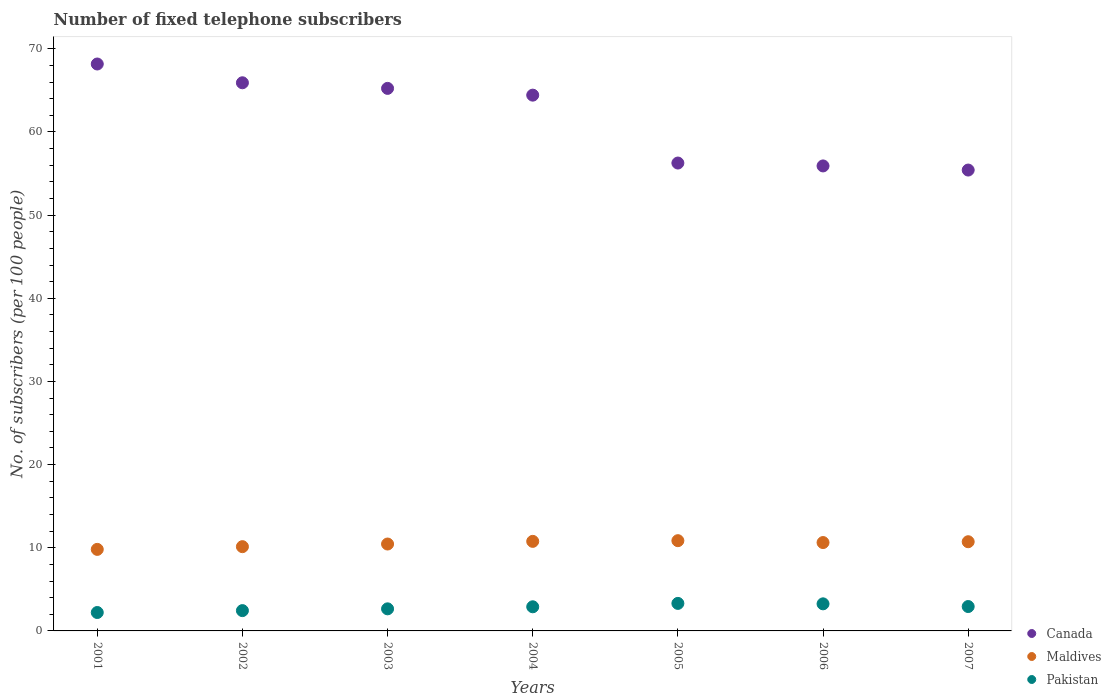How many different coloured dotlines are there?
Provide a succinct answer. 3. What is the number of fixed telephone subscribers in Pakistan in 2004?
Give a very brief answer. 2.9. Across all years, what is the maximum number of fixed telephone subscribers in Canada?
Ensure brevity in your answer.  68.18. Across all years, what is the minimum number of fixed telephone subscribers in Pakistan?
Offer a very short reply. 2.21. In which year was the number of fixed telephone subscribers in Maldives maximum?
Keep it short and to the point. 2005. In which year was the number of fixed telephone subscribers in Canada minimum?
Make the answer very short. 2007. What is the total number of fixed telephone subscribers in Maldives in the graph?
Provide a succinct answer. 73.37. What is the difference between the number of fixed telephone subscribers in Pakistan in 2005 and that in 2007?
Offer a very short reply. 0.38. What is the difference between the number of fixed telephone subscribers in Maldives in 2006 and the number of fixed telephone subscribers in Canada in 2003?
Make the answer very short. -54.62. What is the average number of fixed telephone subscribers in Canada per year?
Ensure brevity in your answer.  61.63. In the year 2003, what is the difference between the number of fixed telephone subscribers in Maldives and number of fixed telephone subscribers in Canada?
Provide a succinct answer. -54.79. In how many years, is the number of fixed telephone subscribers in Canada greater than 38?
Provide a short and direct response. 7. What is the ratio of the number of fixed telephone subscribers in Canada in 2003 to that in 2004?
Ensure brevity in your answer.  1.01. Is the difference between the number of fixed telephone subscribers in Maldives in 2002 and 2005 greater than the difference between the number of fixed telephone subscribers in Canada in 2002 and 2005?
Offer a terse response. No. What is the difference between the highest and the second highest number of fixed telephone subscribers in Canada?
Provide a succinct answer. 2.26. What is the difference between the highest and the lowest number of fixed telephone subscribers in Pakistan?
Give a very brief answer. 1.09. In how many years, is the number of fixed telephone subscribers in Maldives greater than the average number of fixed telephone subscribers in Maldives taken over all years?
Your answer should be very brief. 4. Is it the case that in every year, the sum of the number of fixed telephone subscribers in Pakistan and number of fixed telephone subscribers in Maldives  is greater than the number of fixed telephone subscribers in Canada?
Ensure brevity in your answer.  No. Does the number of fixed telephone subscribers in Canada monotonically increase over the years?
Keep it short and to the point. No. Is the number of fixed telephone subscribers in Pakistan strictly greater than the number of fixed telephone subscribers in Maldives over the years?
Keep it short and to the point. No. Is the number of fixed telephone subscribers in Canada strictly less than the number of fixed telephone subscribers in Pakistan over the years?
Offer a terse response. No. How many dotlines are there?
Your answer should be very brief. 3. How many years are there in the graph?
Provide a short and direct response. 7. Are the values on the major ticks of Y-axis written in scientific E-notation?
Make the answer very short. No. Does the graph contain any zero values?
Your answer should be very brief. No. Does the graph contain grids?
Offer a very short reply. No. How many legend labels are there?
Your response must be concise. 3. How are the legend labels stacked?
Your answer should be very brief. Vertical. What is the title of the graph?
Ensure brevity in your answer.  Number of fixed telephone subscribers. What is the label or title of the X-axis?
Provide a short and direct response. Years. What is the label or title of the Y-axis?
Ensure brevity in your answer.  No. of subscribers (per 100 people). What is the No. of subscribers (per 100 people) in Canada in 2001?
Ensure brevity in your answer.  68.18. What is the No. of subscribers (per 100 people) of Maldives in 2001?
Your response must be concise. 9.81. What is the No. of subscribers (per 100 people) of Pakistan in 2001?
Your response must be concise. 2.21. What is the No. of subscribers (per 100 people) of Canada in 2002?
Ensure brevity in your answer.  65.92. What is the No. of subscribers (per 100 people) in Maldives in 2002?
Make the answer very short. 10.13. What is the No. of subscribers (per 100 people) in Pakistan in 2002?
Provide a short and direct response. 2.44. What is the No. of subscribers (per 100 people) in Canada in 2003?
Give a very brief answer. 65.25. What is the No. of subscribers (per 100 people) in Maldives in 2003?
Provide a succinct answer. 10.45. What is the No. of subscribers (per 100 people) in Pakistan in 2003?
Provide a succinct answer. 2.66. What is the No. of subscribers (per 100 people) of Canada in 2004?
Make the answer very short. 64.43. What is the No. of subscribers (per 100 people) in Maldives in 2004?
Make the answer very short. 10.77. What is the No. of subscribers (per 100 people) in Pakistan in 2004?
Provide a short and direct response. 2.9. What is the No. of subscribers (per 100 people) of Canada in 2005?
Offer a very short reply. 56.27. What is the No. of subscribers (per 100 people) of Maldives in 2005?
Make the answer very short. 10.85. What is the No. of subscribers (per 100 people) of Pakistan in 2005?
Provide a succinct answer. 3.31. What is the No. of subscribers (per 100 people) in Canada in 2006?
Offer a very short reply. 55.92. What is the No. of subscribers (per 100 people) in Maldives in 2006?
Offer a terse response. 10.63. What is the No. of subscribers (per 100 people) in Pakistan in 2006?
Provide a short and direct response. 3.26. What is the No. of subscribers (per 100 people) of Canada in 2007?
Offer a very short reply. 55.42. What is the No. of subscribers (per 100 people) in Maldives in 2007?
Keep it short and to the point. 10.73. What is the No. of subscribers (per 100 people) of Pakistan in 2007?
Provide a succinct answer. 2.93. Across all years, what is the maximum No. of subscribers (per 100 people) of Canada?
Offer a very short reply. 68.18. Across all years, what is the maximum No. of subscribers (per 100 people) in Maldives?
Keep it short and to the point. 10.85. Across all years, what is the maximum No. of subscribers (per 100 people) in Pakistan?
Ensure brevity in your answer.  3.31. Across all years, what is the minimum No. of subscribers (per 100 people) in Canada?
Make the answer very short. 55.42. Across all years, what is the minimum No. of subscribers (per 100 people) of Maldives?
Offer a very short reply. 9.81. Across all years, what is the minimum No. of subscribers (per 100 people) of Pakistan?
Keep it short and to the point. 2.21. What is the total No. of subscribers (per 100 people) of Canada in the graph?
Keep it short and to the point. 431.39. What is the total No. of subscribers (per 100 people) of Maldives in the graph?
Your response must be concise. 73.37. What is the total No. of subscribers (per 100 people) of Pakistan in the graph?
Your response must be concise. 19.71. What is the difference between the No. of subscribers (per 100 people) of Canada in 2001 and that in 2002?
Your response must be concise. 2.26. What is the difference between the No. of subscribers (per 100 people) in Maldives in 2001 and that in 2002?
Ensure brevity in your answer.  -0.33. What is the difference between the No. of subscribers (per 100 people) of Pakistan in 2001 and that in 2002?
Your answer should be very brief. -0.23. What is the difference between the No. of subscribers (per 100 people) of Canada in 2001 and that in 2003?
Your answer should be very brief. 2.93. What is the difference between the No. of subscribers (per 100 people) of Maldives in 2001 and that in 2003?
Offer a very short reply. -0.65. What is the difference between the No. of subscribers (per 100 people) of Pakistan in 2001 and that in 2003?
Provide a succinct answer. -0.44. What is the difference between the No. of subscribers (per 100 people) of Canada in 2001 and that in 2004?
Ensure brevity in your answer.  3.75. What is the difference between the No. of subscribers (per 100 people) of Maldives in 2001 and that in 2004?
Your answer should be very brief. -0.96. What is the difference between the No. of subscribers (per 100 people) in Pakistan in 2001 and that in 2004?
Provide a succinct answer. -0.69. What is the difference between the No. of subscribers (per 100 people) in Canada in 2001 and that in 2005?
Offer a very short reply. 11.91. What is the difference between the No. of subscribers (per 100 people) of Maldives in 2001 and that in 2005?
Your answer should be very brief. -1.05. What is the difference between the No. of subscribers (per 100 people) in Pakistan in 2001 and that in 2005?
Offer a very short reply. -1.09. What is the difference between the No. of subscribers (per 100 people) in Canada in 2001 and that in 2006?
Make the answer very short. 12.26. What is the difference between the No. of subscribers (per 100 people) of Maldives in 2001 and that in 2006?
Give a very brief answer. -0.82. What is the difference between the No. of subscribers (per 100 people) of Pakistan in 2001 and that in 2006?
Provide a short and direct response. -1.04. What is the difference between the No. of subscribers (per 100 people) in Canada in 2001 and that in 2007?
Make the answer very short. 12.75. What is the difference between the No. of subscribers (per 100 people) in Maldives in 2001 and that in 2007?
Provide a succinct answer. -0.92. What is the difference between the No. of subscribers (per 100 people) in Pakistan in 2001 and that in 2007?
Your answer should be compact. -0.72. What is the difference between the No. of subscribers (per 100 people) of Canada in 2002 and that in 2003?
Offer a terse response. 0.67. What is the difference between the No. of subscribers (per 100 people) in Maldives in 2002 and that in 2003?
Your response must be concise. -0.32. What is the difference between the No. of subscribers (per 100 people) of Pakistan in 2002 and that in 2003?
Provide a short and direct response. -0.21. What is the difference between the No. of subscribers (per 100 people) in Canada in 2002 and that in 2004?
Make the answer very short. 1.49. What is the difference between the No. of subscribers (per 100 people) of Maldives in 2002 and that in 2004?
Make the answer very short. -0.64. What is the difference between the No. of subscribers (per 100 people) of Pakistan in 2002 and that in 2004?
Give a very brief answer. -0.46. What is the difference between the No. of subscribers (per 100 people) in Canada in 2002 and that in 2005?
Give a very brief answer. 9.65. What is the difference between the No. of subscribers (per 100 people) in Maldives in 2002 and that in 2005?
Provide a short and direct response. -0.72. What is the difference between the No. of subscribers (per 100 people) of Pakistan in 2002 and that in 2005?
Keep it short and to the point. -0.87. What is the difference between the No. of subscribers (per 100 people) of Canada in 2002 and that in 2006?
Ensure brevity in your answer.  10. What is the difference between the No. of subscribers (per 100 people) in Maldives in 2002 and that in 2006?
Your response must be concise. -0.49. What is the difference between the No. of subscribers (per 100 people) in Pakistan in 2002 and that in 2006?
Keep it short and to the point. -0.81. What is the difference between the No. of subscribers (per 100 people) in Canada in 2002 and that in 2007?
Provide a short and direct response. 10.5. What is the difference between the No. of subscribers (per 100 people) in Maldives in 2002 and that in 2007?
Ensure brevity in your answer.  -0.59. What is the difference between the No. of subscribers (per 100 people) in Pakistan in 2002 and that in 2007?
Provide a succinct answer. -0.49. What is the difference between the No. of subscribers (per 100 people) in Canada in 2003 and that in 2004?
Offer a terse response. 0.81. What is the difference between the No. of subscribers (per 100 people) in Maldives in 2003 and that in 2004?
Keep it short and to the point. -0.32. What is the difference between the No. of subscribers (per 100 people) of Pakistan in 2003 and that in 2004?
Provide a succinct answer. -0.25. What is the difference between the No. of subscribers (per 100 people) in Canada in 2003 and that in 2005?
Offer a terse response. 8.98. What is the difference between the No. of subscribers (per 100 people) of Maldives in 2003 and that in 2005?
Make the answer very short. -0.4. What is the difference between the No. of subscribers (per 100 people) of Pakistan in 2003 and that in 2005?
Keep it short and to the point. -0.65. What is the difference between the No. of subscribers (per 100 people) in Canada in 2003 and that in 2006?
Provide a short and direct response. 9.33. What is the difference between the No. of subscribers (per 100 people) in Maldives in 2003 and that in 2006?
Make the answer very short. -0.18. What is the difference between the No. of subscribers (per 100 people) of Pakistan in 2003 and that in 2006?
Provide a short and direct response. -0.6. What is the difference between the No. of subscribers (per 100 people) in Canada in 2003 and that in 2007?
Give a very brief answer. 9.82. What is the difference between the No. of subscribers (per 100 people) of Maldives in 2003 and that in 2007?
Your response must be concise. -0.28. What is the difference between the No. of subscribers (per 100 people) in Pakistan in 2003 and that in 2007?
Your response must be concise. -0.28. What is the difference between the No. of subscribers (per 100 people) in Canada in 2004 and that in 2005?
Give a very brief answer. 8.16. What is the difference between the No. of subscribers (per 100 people) of Maldives in 2004 and that in 2005?
Offer a terse response. -0.08. What is the difference between the No. of subscribers (per 100 people) of Pakistan in 2004 and that in 2005?
Provide a short and direct response. -0.41. What is the difference between the No. of subscribers (per 100 people) in Canada in 2004 and that in 2006?
Make the answer very short. 8.51. What is the difference between the No. of subscribers (per 100 people) of Maldives in 2004 and that in 2006?
Give a very brief answer. 0.14. What is the difference between the No. of subscribers (per 100 people) in Pakistan in 2004 and that in 2006?
Keep it short and to the point. -0.35. What is the difference between the No. of subscribers (per 100 people) in Canada in 2004 and that in 2007?
Offer a very short reply. 9.01. What is the difference between the No. of subscribers (per 100 people) in Maldives in 2004 and that in 2007?
Offer a very short reply. 0.04. What is the difference between the No. of subscribers (per 100 people) in Pakistan in 2004 and that in 2007?
Your answer should be very brief. -0.03. What is the difference between the No. of subscribers (per 100 people) of Canada in 2005 and that in 2006?
Provide a short and direct response. 0.35. What is the difference between the No. of subscribers (per 100 people) in Maldives in 2005 and that in 2006?
Your answer should be very brief. 0.23. What is the difference between the No. of subscribers (per 100 people) of Pakistan in 2005 and that in 2006?
Keep it short and to the point. 0.05. What is the difference between the No. of subscribers (per 100 people) in Canada in 2005 and that in 2007?
Keep it short and to the point. 0.84. What is the difference between the No. of subscribers (per 100 people) of Maldives in 2005 and that in 2007?
Give a very brief answer. 0.13. What is the difference between the No. of subscribers (per 100 people) of Pakistan in 2005 and that in 2007?
Provide a short and direct response. 0.38. What is the difference between the No. of subscribers (per 100 people) of Canada in 2006 and that in 2007?
Keep it short and to the point. 0.5. What is the difference between the No. of subscribers (per 100 people) of Maldives in 2006 and that in 2007?
Give a very brief answer. -0.1. What is the difference between the No. of subscribers (per 100 people) in Pakistan in 2006 and that in 2007?
Your response must be concise. 0.32. What is the difference between the No. of subscribers (per 100 people) in Canada in 2001 and the No. of subscribers (per 100 people) in Maldives in 2002?
Keep it short and to the point. 58.04. What is the difference between the No. of subscribers (per 100 people) in Canada in 2001 and the No. of subscribers (per 100 people) in Pakistan in 2002?
Give a very brief answer. 65.74. What is the difference between the No. of subscribers (per 100 people) in Maldives in 2001 and the No. of subscribers (per 100 people) in Pakistan in 2002?
Provide a succinct answer. 7.36. What is the difference between the No. of subscribers (per 100 people) of Canada in 2001 and the No. of subscribers (per 100 people) of Maldives in 2003?
Ensure brevity in your answer.  57.73. What is the difference between the No. of subscribers (per 100 people) in Canada in 2001 and the No. of subscribers (per 100 people) in Pakistan in 2003?
Your response must be concise. 65.52. What is the difference between the No. of subscribers (per 100 people) of Maldives in 2001 and the No. of subscribers (per 100 people) of Pakistan in 2003?
Ensure brevity in your answer.  7.15. What is the difference between the No. of subscribers (per 100 people) of Canada in 2001 and the No. of subscribers (per 100 people) of Maldives in 2004?
Give a very brief answer. 57.41. What is the difference between the No. of subscribers (per 100 people) of Canada in 2001 and the No. of subscribers (per 100 people) of Pakistan in 2004?
Your answer should be very brief. 65.28. What is the difference between the No. of subscribers (per 100 people) in Maldives in 2001 and the No. of subscribers (per 100 people) in Pakistan in 2004?
Make the answer very short. 6.9. What is the difference between the No. of subscribers (per 100 people) in Canada in 2001 and the No. of subscribers (per 100 people) in Maldives in 2005?
Offer a very short reply. 57.32. What is the difference between the No. of subscribers (per 100 people) of Canada in 2001 and the No. of subscribers (per 100 people) of Pakistan in 2005?
Keep it short and to the point. 64.87. What is the difference between the No. of subscribers (per 100 people) of Maldives in 2001 and the No. of subscribers (per 100 people) of Pakistan in 2005?
Make the answer very short. 6.5. What is the difference between the No. of subscribers (per 100 people) in Canada in 2001 and the No. of subscribers (per 100 people) in Maldives in 2006?
Offer a terse response. 57.55. What is the difference between the No. of subscribers (per 100 people) of Canada in 2001 and the No. of subscribers (per 100 people) of Pakistan in 2006?
Offer a terse response. 64.92. What is the difference between the No. of subscribers (per 100 people) in Maldives in 2001 and the No. of subscribers (per 100 people) in Pakistan in 2006?
Make the answer very short. 6.55. What is the difference between the No. of subscribers (per 100 people) in Canada in 2001 and the No. of subscribers (per 100 people) in Maldives in 2007?
Make the answer very short. 57.45. What is the difference between the No. of subscribers (per 100 people) in Canada in 2001 and the No. of subscribers (per 100 people) in Pakistan in 2007?
Keep it short and to the point. 65.25. What is the difference between the No. of subscribers (per 100 people) in Maldives in 2001 and the No. of subscribers (per 100 people) in Pakistan in 2007?
Your answer should be very brief. 6.87. What is the difference between the No. of subscribers (per 100 people) in Canada in 2002 and the No. of subscribers (per 100 people) in Maldives in 2003?
Give a very brief answer. 55.47. What is the difference between the No. of subscribers (per 100 people) of Canada in 2002 and the No. of subscribers (per 100 people) of Pakistan in 2003?
Offer a terse response. 63.26. What is the difference between the No. of subscribers (per 100 people) in Maldives in 2002 and the No. of subscribers (per 100 people) in Pakistan in 2003?
Provide a short and direct response. 7.48. What is the difference between the No. of subscribers (per 100 people) in Canada in 2002 and the No. of subscribers (per 100 people) in Maldives in 2004?
Provide a succinct answer. 55.15. What is the difference between the No. of subscribers (per 100 people) in Canada in 2002 and the No. of subscribers (per 100 people) in Pakistan in 2004?
Offer a very short reply. 63.02. What is the difference between the No. of subscribers (per 100 people) in Maldives in 2002 and the No. of subscribers (per 100 people) in Pakistan in 2004?
Make the answer very short. 7.23. What is the difference between the No. of subscribers (per 100 people) of Canada in 2002 and the No. of subscribers (per 100 people) of Maldives in 2005?
Give a very brief answer. 55.07. What is the difference between the No. of subscribers (per 100 people) in Canada in 2002 and the No. of subscribers (per 100 people) in Pakistan in 2005?
Your answer should be very brief. 62.61. What is the difference between the No. of subscribers (per 100 people) of Maldives in 2002 and the No. of subscribers (per 100 people) of Pakistan in 2005?
Offer a very short reply. 6.82. What is the difference between the No. of subscribers (per 100 people) of Canada in 2002 and the No. of subscribers (per 100 people) of Maldives in 2006?
Give a very brief answer. 55.29. What is the difference between the No. of subscribers (per 100 people) of Canada in 2002 and the No. of subscribers (per 100 people) of Pakistan in 2006?
Your response must be concise. 62.66. What is the difference between the No. of subscribers (per 100 people) of Maldives in 2002 and the No. of subscribers (per 100 people) of Pakistan in 2006?
Offer a very short reply. 6.88. What is the difference between the No. of subscribers (per 100 people) of Canada in 2002 and the No. of subscribers (per 100 people) of Maldives in 2007?
Provide a succinct answer. 55.19. What is the difference between the No. of subscribers (per 100 people) of Canada in 2002 and the No. of subscribers (per 100 people) of Pakistan in 2007?
Your response must be concise. 62.99. What is the difference between the No. of subscribers (per 100 people) of Maldives in 2002 and the No. of subscribers (per 100 people) of Pakistan in 2007?
Provide a short and direct response. 7.2. What is the difference between the No. of subscribers (per 100 people) of Canada in 2003 and the No. of subscribers (per 100 people) of Maldives in 2004?
Give a very brief answer. 54.48. What is the difference between the No. of subscribers (per 100 people) in Canada in 2003 and the No. of subscribers (per 100 people) in Pakistan in 2004?
Your answer should be very brief. 62.34. What is the difference between the No. of subscribers (per 100 people) in Maldives in 2003 and the No. of subscribers (per 100 people) in Pakistan in 2004?
Keep it short and to the point. 7.55. What is the difference between the No. of subscribers (per 100 people) in Canada in 2003 and the No. of subscribers (per 100 people) in Maldives in 2005?
Ensure brevity in your answer.  54.39. What is the difference between the No. of subscribers (per 100 people) in Canada in 2003 and the No. of subscribers (per 100 people) in Pakistan in 2005?
Provide a succinct answer. 61.94. What is the difference between the No. of subscribers (per 100 people) of Maldives in 2003 and the No. of subscribers (per 100 people) of Pakistan in 2005?
Give a very brief answer. 7.14. What is the difference between the No. of subscribers (per 100 people) of Canada in 2003 and the No. of subscribers (per 100 people) of Maldives in 2006?
Your answer should be very brief. 54.62. What is the difference between the No. of subscribers (per 100 people) in Canada in 2003 and the No. of subscribers (per 100 people) in Pakistan in 2006?
Offer a very short reply. 61.99. What is the difference between the No. of subscribers (per 100 people) in Maldives in 2003 and the No. of subscribers (per 100 people) in Pakistan in 2006?
Your answer should be compact. 7.19. What is the difference between the No. of subscribers (per 100 people) in Canada in 2003 and the No. of subscribers (per 100 people) in Maldives in 2007?
Give a very brief answer. 54.52. What is the difference between the No. of subscribers (per 100 people) of Canada in 2003 and the No. of subscribers (per 100 people) of Pakistan in 2007?
Provide a succinct answer. 62.31. What is the difference between the No. of subscribers (per 100 people) of Maldives in 2003 and the No. of subscribers (per 100 people) of Pakistan in 2007?
Provide a succinct answer. 7.52. What is the difference between the No. of subscribers (per 100 people) in Canada in 2004 and the No. of subscribers (per 100 people) in Maldives in 2005?
Offer a terse response. 53.58. What is the difference between the No. of subscribers (per 100 people) in Canada in 2004 and the No. of subscribers (per 100 people) in Pakistan in 2005?
Provide a short and direct response. 61.12. What is the difference between the No. of subscribers (per 100 people) of Maldives in 2004 and the No. of subscribers (per 100 people) of Pakistan in 2005?
Your answer should be very brief. 7.46. What is the difference between the No. of subscribers (per 100 people) in Canada in 2004 and the No. of subscribers (per 100 people) in Maldives in 2006?
Your response must be concise. 53.81. What is the difference between the No. of subscribers (per 100 people) in Canada in 2004 and the No. of subscribers (per 100 people) in Pakistan in 2006?
Offer a very short reply. 61.18. What is the difference between the No. of subscribers (per 100 people) in Maldives in 2004 and the No. of subscribers (per 100 people) in Pakistan in 2006?
Your response must be concise. 7.51. What is the difference between the No. of subscribers (per 100 people) of Canada in 2004 and the No. of subscribers (per 100 people) of Maldives in 2007?
Provide a short and direct response. 53.71. What is the difference between the No. of subscribers (per 100 people) in Canada in 2004 and the No. of subscribers (per 100 people) in Pakistan in 2007?
Offer a terse response. 61.5. What is the difference between the No. of subscribers (per 100 people) of Maldives in 2004 and the No. of subscribers (per 100 people) of Pakistan in 2007?
Make the answer very short. 7.84. What is the difference between the No. of subscribers (per 100 people) in Canada in 2005 and the No. of subscribers (per 100 people) in Maldives in 2006?
Offer a terse response. 45.64. What is the difference between the No. of subscribers (per 100 people) of Canada in 2005 and the No. of subscribers (per 100 people) of Pakistan in 2006?
Your answer should be compact. 53.01. What is the difference between the No. of subscribers (per 100 people) of Maldives in 2005 and the No. of subscribers (per 100 people) of Pakistan in 2006?
Provide a short and direct response. 7.6. What is the difference between the No. of subscribers (per 100 people) of Canada in 2005 and the No. of subscribers (per 100 people) of Maldives in 2007?
Your response must be concise. 45.54. What is the difference between the No. of subscribers (per 100 people) in Canada in 2005 and the No. of subscribers (per 100 people) in Pakistan in 2007?
Keep it short and to the point. 53.34. What is the difference between the No. of subscribers (per 100 people) in Maldives in 2005 and the No. of subscribers (per 100 people) in Pakistan in 2007?
Offer a terse response. 7.92. What is the difference between the No. of subscribers (per 100 people) of Canada in 2006 and the No. of subscribers (per 100 people) of Maldives in 2007?
Offer a terse response. 45.19. What is the difference between the No. of subscribers (per 100 people) of Canada in 2006 and the No. of subscribers (per 100 people) of Pakistan in 2007?
Provide a succinct answer. 52.99. What is the difference between the No. of subscribers (per 100 people) in Maldives in 2006 and the No. of subscribers (per 100 people) in Pakistan in 2007?
Offer a very short reply. 7.7. What is the average No. of subscribers (per 100 people) in Canada per year?
Provide a short and direct response. 61.63. What is the average No. of subscribers (per 100 people) of Maldives per year?
Offer a very short reply. 10.48. What is the average No. of subscribers (per 100 people) in Pakistan per year?
Make the answer very short. 2.82. In the year 2001, what is the difference between the No. of subscribers (per 100 people) of Canada and No. of subscribers (per 100 people) of Maldives?
Offer a very short reply. 58.37. In the year 2001, what is the difference between the No. of subscribers (per 100 people) in Canada and No. of subscribers (per 100 people) in Pakistan?
Offer a terse response. 65.96. In the year 2001, what is the difference between the No. of subscribers (per 100 people) in Maldives and No. of subscribers (per 100 people) in Pakistan?
Your answer should be very brief. 7.59. In the year 2002, what is the difference between the No. of subscribers (per 100 people) in Canada and No. of subscribers (per 100 people) in Maldives?
Provide a short and direct response. 55.79. In the year 2002, what is the difference between the No. of subscribers (per 100 people) in Canada and No. of subscribers (per 100 people) in Pakistan?
Your response must be concise. 63.48. In the year 2002, what is the difference between the No. of subscribers (per 100 people) in Maldives and No. of subscribers (per 100 people) in Pakistan?
Your answer should be very brief. 7.69. In the year 2003, what is the difference between the No. of subscribers (per 100 people) of Canada and No. of subscribers (per 100 people) of Maldives?
Your answer should be very brief. 54.79. In the year 2003, what is the difference between the No. of subscribers (per 100 people) in Canada and No. of subscribers (per 100 people) in Pakistan?
Make the answer very short. 62.59. In the year 2003, what is the difference between the No. of subscribers (per 100 people) of Maldives and No. of subscribers (per 100 people) of Pakistan?
Offer a very short reply. 7.8. In the year 2004, what is the difference between the No. of subscribers (per 100 people) in Canada and No. of subscribers (per 100 people) in Maldives?
Offer a terse response. 53.66. In the year 2004, what is the difference between the No. of subscribers (per 100 people) of Canada and No. of subscribers (per 100 people) of Pakistan?
Your response must be concise. 61.53. In the year 2004, what is the difference between the No. of subscribers (per 100 people) in Maldives and No. of subscribers (per 100 people) in Pakistan?
Provide a short and direct response. 7.87. In the year 2005, what is the difference between the No. of subscribers (per 100 people) in Canada and No. of subscribers (per 100 people) in Maldives?
Keep it short and to the point. 45.41. In the year 2005, what is the difference between the No. of subscribers (per 100 people) of Canada and No. of subscribers (per 100 people) of Pakistan?
Your answer should be compact. 52.96. In the year 2005, what is the difference between the No. of subscribers (per 100 people) in Maldives and No. of subscribers (per 100 people) in Pakistan?
Make the answer very short. 7.54. In the year 2006, what is the difference between the No. of subscribers (per 100 people) of Canada and No. of subscribers (per 100 people) of Maldives?
Keep it short and to the point. 45.29. In the year 2006, what is the difference between the No. of subscribers (per 100 people) of Canada and No. of subscribers (per 100 people) of Pakistan?
Give a very brief answer. 52.66. In the year 2006, what is the difference between the No. of subscribers (per 100 people) in Maldives and No. of subscribers (per 100 people) in Pakistan?
Give a very brief answer. 7.37. In the year 2007, what is the difference between the No. of subscribers (per 100 people) of Canada and No. of subscribers (per 100 people) of Maldives?
Give a very brief answer. 44.7. In the year 2007, what is the difference between the No. of subscribers (per 100 people) in Canada and No. of subscribers (per 100 people) in Pakistan?
Your answer should be compact. 52.49. In the year 2007, what is the difference between the No. of subscribers (per 100 people) in Maldives and No. of subscribers (per 100 people) in Pakistan?
Offer a terse response. 7.79. What is the ratio of the No. of subscribers (per 100 people) in Canada in 2001 to that in 2002?
Provide a succinct answer. 1.03. What is the ratio of the No. of subscribers (per 100 people) in Pakistan in 2001 to that in 2002?
Your response must be concise. 0.91. What is the ratio of the No. of subscribers (per 100 people) in Canada in 2001 to that in 2003?
Offer a very short reply. 1.04. What is the ratio of the No. of subscribers (per 100 people) in Maldives in 2001 to that in 2003?
Give a very brief answer. 0.94. What is the ratio of the No. of subscribers (per 100 people) in Pakistan in 2001 to that in 2003?
Give a very brief answer. 0.83. What is the ratio of the No. of subscribers (per 100 people) of Canada in 2001 to that in 2004?
Ensure brevity in your answer.  1.06. What is the ratio of the No. of subscribers (per 100 people) in Maldives in 2001 to that in 2004?
Offer a terse response. 0.91. What is the ratio of the No. of subscribers (per 100 people) in Pakistan in 2001 to that in 2004?
Make the answer very short. 0.76. What is the ratio of the No. of subscribers (per 100 people) of Canada in 2001 to that in 2005?
Your answer should be compact. 1.21. What is the ratio of the No. of subscribers (per 100 people) in Maldives in 2001 to that in 2005?
Provide a short and direct response. 0.9. What is the ratio of the No. of subscribers (per 100 people) of Pakistan in 2001 to that in 2005?
Offer a very short reply. 0.67. What is the ratio of the No. of subscribers (per 100 people) of Canada in 2001 to that in 2006?
Offer a very short reply. 1.22. What is the ratio of the No. of subscribers (per 100 people) in Maldives in 2001 to that in 2006?
Offer a very short reply. 0.92. What is the ratio of the No. of subscribers (per 100 people) of Pakistan in 2001 to that in 2006?
Offer a terse response. 0.68. What is the ratio of the No. of subscribers (per 100 people) in Canada in 2001 to that in 2007?
Provide a short and direct response. 1.23. What is the ratio of the No. of subscribers (per 100 people) of Maldives in 2001 to that in 2007?
Give a very brief answer. 0.91. What is the ratio of the No. of subscribers (per 100 people) of Pakistan in 2001 to that in 2007?
Provide a succinct answer. 0.76. What is the ratio of the No. of subscribers (per 100 people) in Canada in 2002 to that in 2003?
Make the answer very short. 1.01. What is the ratio of the No. of subscribers (per 100 people) in Maldives in 2002 to that in 2003?
Your answer should be very brief. 0.97. What is the ratio of the No. of subscribers (per 100 people) of Pakistan in 2002 to that in 2003?
Offer a terse response. 0.92. What is the ratio of the No. of subscribers (per 100 people) of Canada in 2002 to that in 2004?
Offer a terse response. 1.02. What is the ratio of the No. of subscribers (per 100 people) in Maldives in 2002 to that in 2004?
Provide a short and direct response. 0.94. What is the ratio of the No. of subscribers (per 100 people) in Pakistan in 2002 to that in 2004?
Your answer should be very brief. 0.84. What is the ratio of the No. of subscribers (per 100 people) of Canada in 2002 to that in 2005?
Offer a terse response. 1.17. What is the ratio of the No. of subscribers (per 100 people) in Maldives in 2002 to that in 2005?
Provide a succinct answer. 0.93. What is the ratio of the No. of subscribers (per 100 people) of Pakistan in 2002 to that in 2005?
Offer a very short reply. 0.74. What is the ratio of the No. of subscribers (per 100 people) of Canada in 2002 to that in 2006?
Provide a succinct answer. 1.18. What is the ratio of the No. of subscribers (per 100 people) in Maldives in 2002 to that in 2006?
Give a very brief answer. 0.95. What is the ratio of the No. of subscribers (per 100 people) of Pakistan in 2002 to that in 2006?
Provide a short and direct response. 0.75. What is the ratio of the No. of subscribers (per 100 people) of Canada in 2002 to that in 2007?
Offer a very short reply. 1.19. What is the ratio of the No. of subscribers (per 100 people) of Maldives in 2002 to that in 2007?
Provide a succinct answer. 0.94. What is the ratio of the No. of subscribers (per 100 people) in Pakistan in 2002 to that in 2007?
Your answer should be very brief. 0.83. What is the ratio of the No. of subscribers (per 100 people) in Canada in 2003 to that in 2004?
Your answer should be very brief. 1.01. What is the ratio of the No. of subscribers (per 100 people) in Maldives in 2003 to that in 2004?
Keep it short and to the point. 0.97. What is the ratio of the No. of subscribers (per 100 people) of Pakistan in 2003 to that in 2004?
Offer a very short reply. 0.92. What is the ratio of the No. of subscribers (per 100 people) of Canada in 2003 to that in 2005?
Give a very brief answer. 1.16. What is the ratio of the No. of subscribers (per 100 people) in Maldives in 2003 to that in 2005?
Your answer should be compact. 0.96. What is the ratio of the No. of subscribers (per 100 people) in Pakistan in 2003 to that in 2005?
Provide a short and direct response. 0.8. What is the ratio of the No. of subscribers (per 100 people) of Canada in 2003 to that in 2006?
Your answer should be compact. 1.17. What is the ratio of the No. of subscribers (per 100 people) in Maldives in 2003 to that in 2006?
Your response must be concise. 0.98. What is the ratio of the No. of subscribers (per 100 people) of Pakistan in 2003 to that in 2006?
Your response must be concise. 0.82. What is the ratio of the No. of subscribers (per 100 people) of Canada in 2003 to that in 2007?
Your answer should be compact. 1.18. What is the ratio of the No. of subscribers (per 100 people) of Maldives in 2003 to that in 2007?
Provide a short and direct response. 0.97. What is the ratio of the No. of subscribers (per 100 people) of Pakistan in 2003 to that in 2007?
Ensure brevity in your answer.  0.91. What is the ratio of the No. of subscribers (per 100 people) of Canada in 2004 to that in 2005?
Offer a very short reply. 1.15. What is the ratio of the No. of subscribers (per 100 people) of Pakistan in 2004 to that in 2005?
Provide a short and direct response. 0.88. What is the ratio of the No. of subscribers (per 100 people) in Canada in 2004 to that in 2006?
Your answer should be compact. 1.15. What is the ratio of the No. of subscribers (per 100 people) of Maldives in 2004 to that in 2006?
Your answer should be compact. 1.01. What is the ratio of the No. of subscribers (per 100 people) in Pakistan in 2004 to that in 2006?
Provide a succinct answer. 0.89. What is the ratio of the No. of subscribers (per 100 people) in Canada in 2004 to that in 2007?
Make the answer very short. 1.16. What is the ratio of the No. of subscribers (per 100 people) in Maldives in 2004 to that in 2007?
Your response must be concise. 1. What is the ratio of the No. of subscribers (per 100 people) in Pakistan in 2004 to that in 2007?
Your response must be concise. 0.99. What is the ratio of the No. of subscribers (per 100 people) in Maldives in 2005 to that in 2006?
Offer a terse response. 1.02. What is the ratio of the No. of subscribers (per 100 people) in Pakistan in 2005 to that in 2006?
Keep it short and to the point. 1.02. What is the ratio of the No. of subscribers (per 100 people) of Canada in 2005 to that in 2007?
Your answer should be compact. 1.02. What is the ratio of the No. of subscribers (per 100 people) in Maldives in 2005 to that in 2007?
Your answer should be compact. 1.01. What is the ratio of the No. of subscribers (per 100 people) in Pakistan in 2005 to that in 2007?
Your answer should be compact. 1.13. What is the ratio of the No. of subscribers (per 100 people) in Canada in 2006 to that in 2007?
Offer a terse response. 1.01. What is the ratio of the No. of subscribers (per 100 people) in Pakistan in 2006 to that in 2007?
Provide a short and direct response. 1.11. What is the difference between the highest and the second highest No. of subscribers (per 100 people) in Canada?
Give a very brief answer. 2.26. What is the difference between the highest and the second highest No. of subscribers (per 100 people) of Maldives?
Provide a succinct answer. 0.08. What is the difference between the highest and the second highest No. of subscribers (per 100 people) in Pakistan?
Your answer should be very brief. 0.05. What is the difference between the highest and the lowest No. of subscribers (per 100 people) in Canada?
Provide a succinct answer. 12.75. What is the difference between the highest and the lowest No. of subscribers (per 100 people) of Maldives?
Your response must be concise. 1.05. What is the difference between the highest and the lowest No. of subscribers (per 100 people) in Pakistan?
Your answer should be compact. 1.09. 